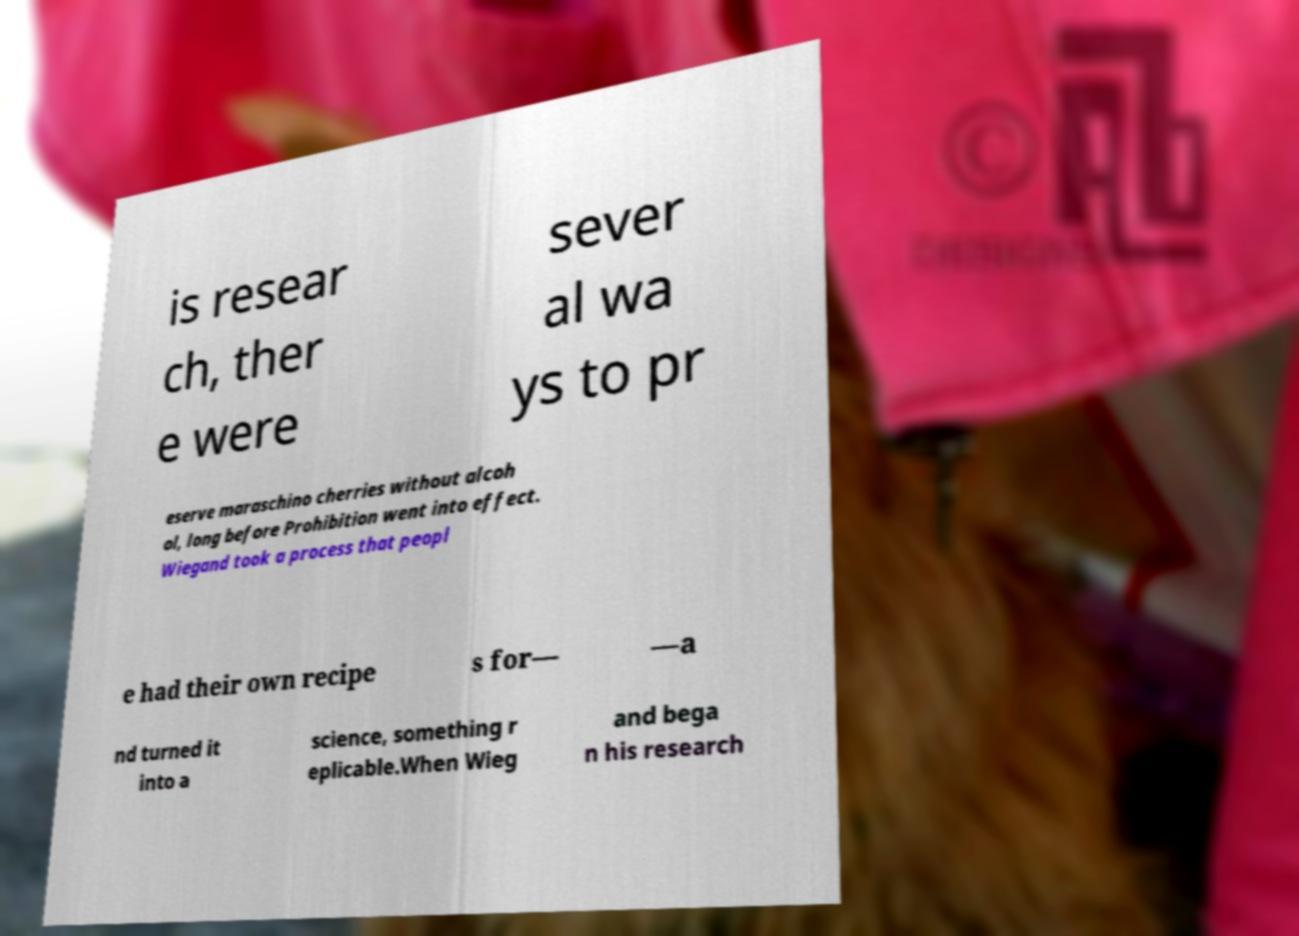For documentation purposes, I need the text within this image transcribed. Could you provide that? is resear ch, ther e were sever al wa ys to pr eserve maraschino cherries without alcoh ol, long before Prohibition went into effect. Wiegand took a process that peopl e had their own recipe s for— —a nd turned it into a science, something r eplicable.When Wieg and bega n his research 